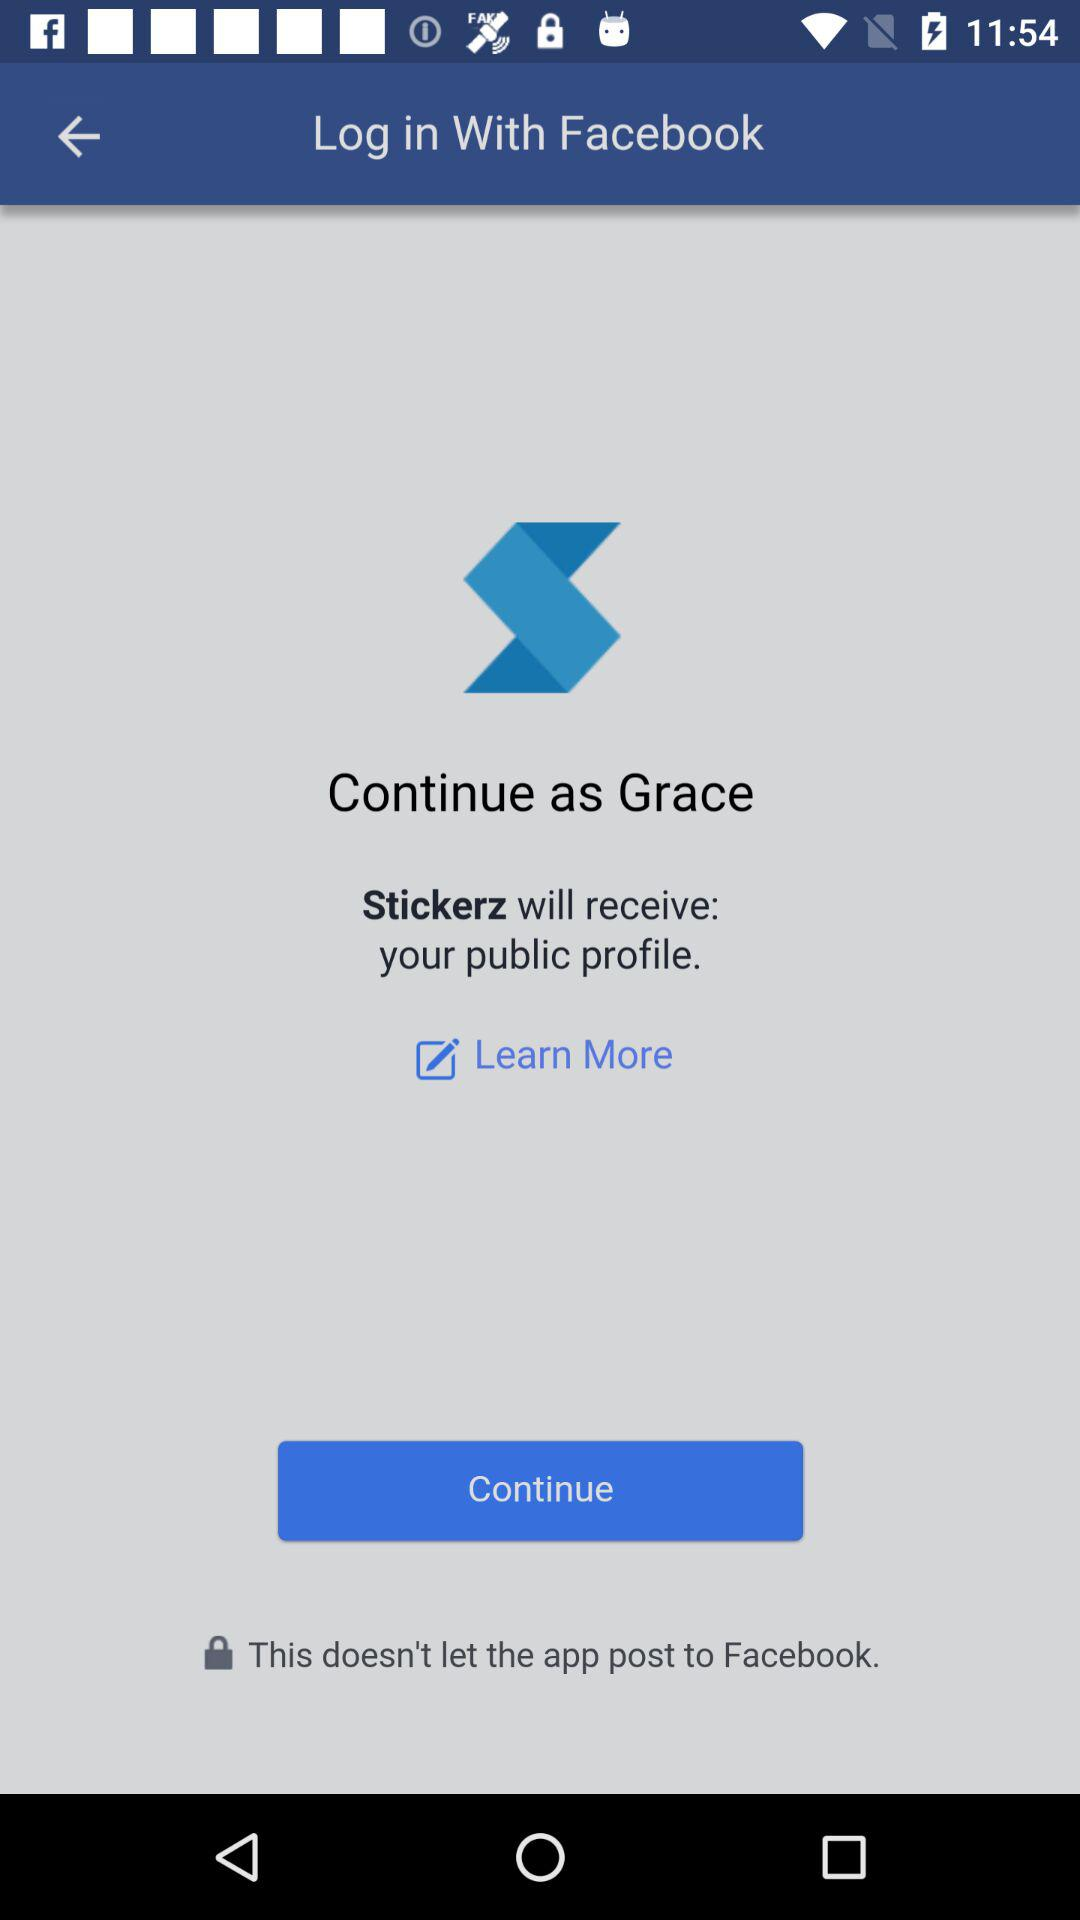When did "Grace" sign up?
When the provided information is insufficient, respond with <no answer>. <no answer> 